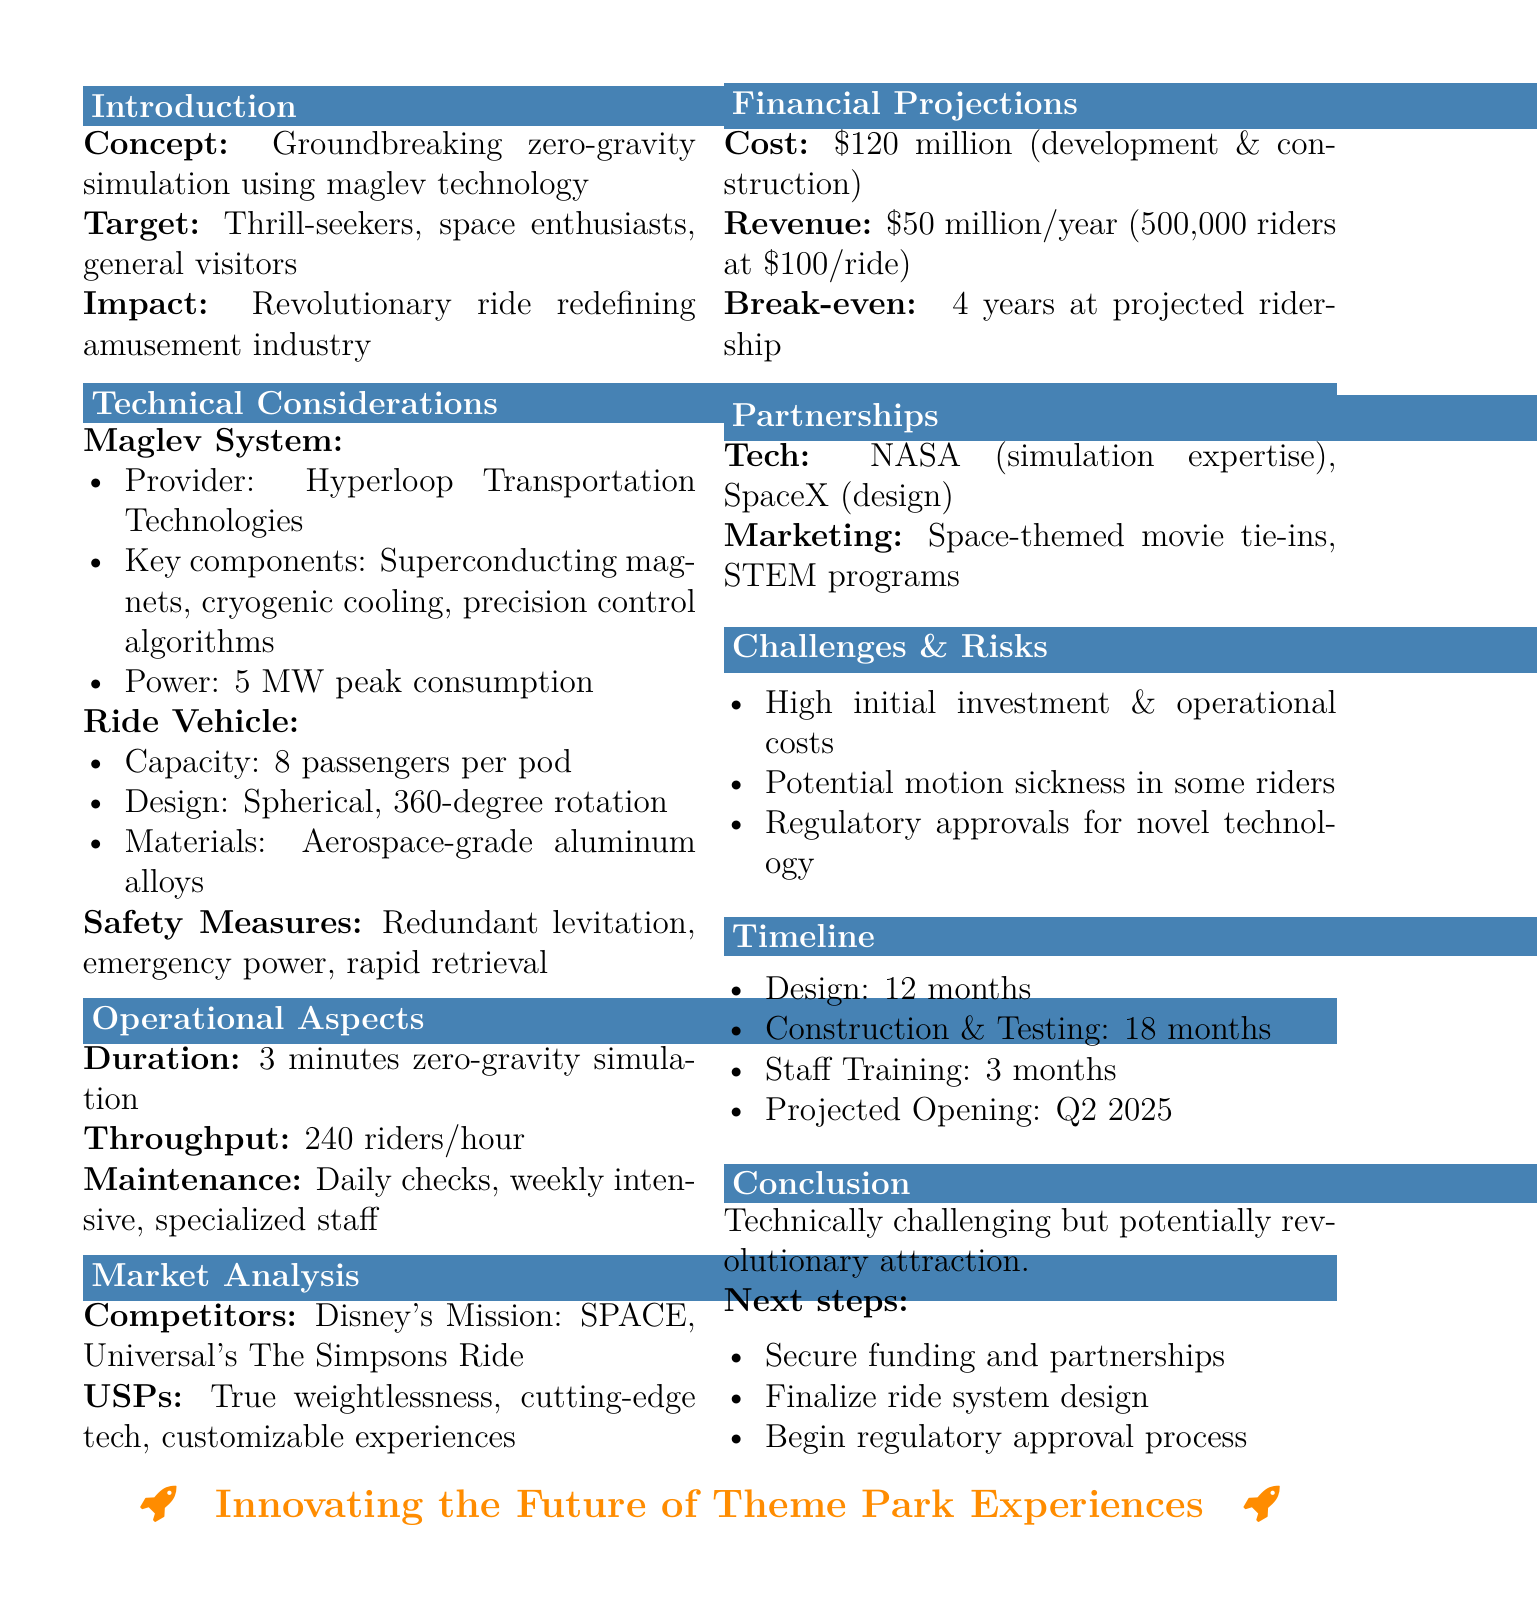What is the title of the memo? The title of the memo is stated at the top, which is "Feasibility Study: Zero-Gravity Simulation Ride Using Magnetic Levitation Technology."
Answer: Feasibility Study: Zero-Gravity Simulation Ride Using Magnetic Levitation Technology Who is the provider of the maglev system? The provider of the maglev system is mentioned in the technical considerations section.
Answer: Hyperloop Transportation Technologies What is the capacity of the ride vehicle? The capacity is specified in the ride vehicle details.
Answer: 8 passengers per pod What is the estimated cost for ride development? The estimated cost for ride development is clearly stated in financial projections.
Answer: $120 million What is the projected opening date? The projected opening date is mentioned in the timeline of the document.
Answer: Q2 2025 What challenges may affect the ride's implementation? The document outlines some challenges and risks associated with the ride.
Answer: High initial investment and operational costs How long is the ride duration? The ride duration is explicitly provided in the operational aspects section.
Answer: 3 minutes What are the unique selling points? The unique selling points are listed in the market analysis section of the document.
Answer: True weightlessness sensation, cutting-edge technology application, customizable ride experiences What is the revenue forecast based on ridership? The revenue forecast is given based on estimated ridership numbers in the financial projections.
Answer: $50 million annual revenue based on 500,000 riders at $100 per ride 